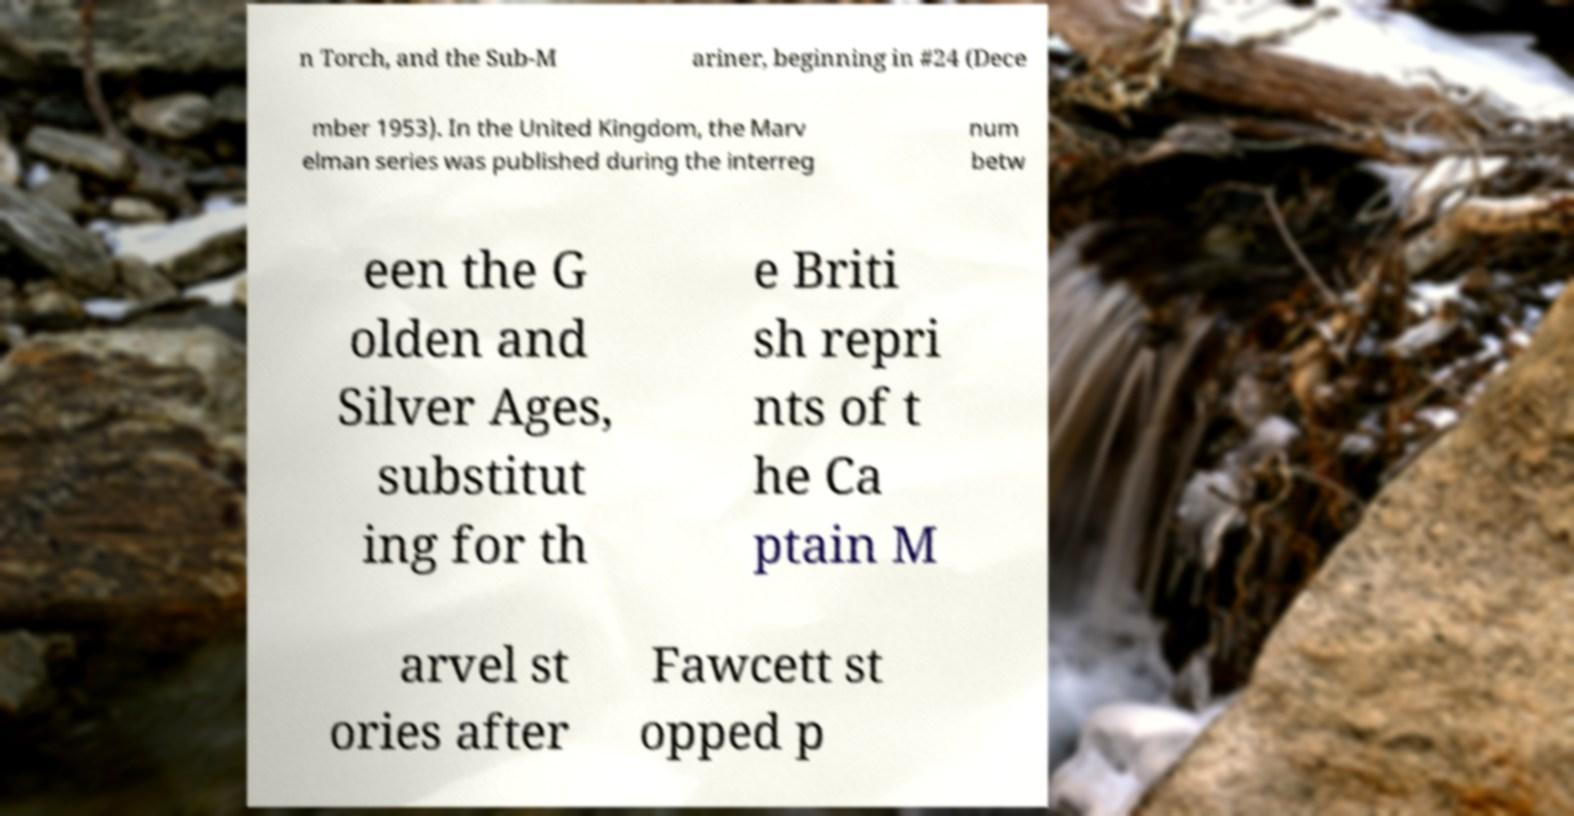Please read and relay the text visible in this image. What does it say? n Torch, and the Sub-M ariner, beginning in #24 (Dece mber 1953). In the United Kingdom, the Marv elman series was published during the interreg num betw een the G olden and Silver Ages, substitut ing for th e Briti sh repri nts of t he Ca ptain M arvel st ories after Fawcett st opped p 